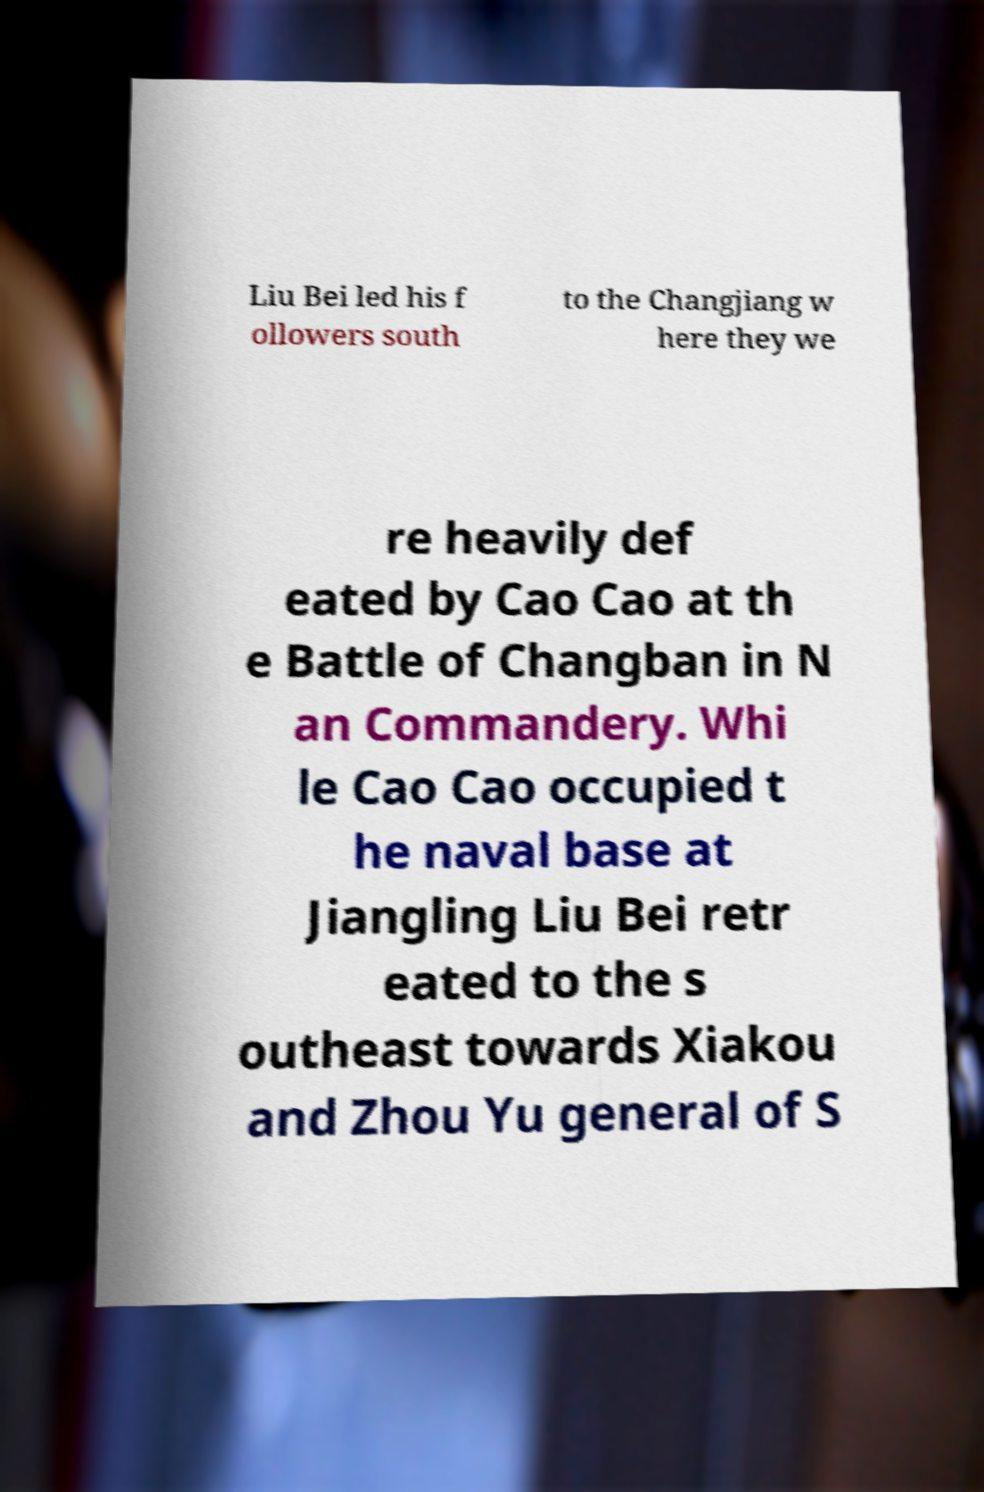Can you read and provide the text displayed in the image?This photo seems to have some interesting text. Can you extract and type it out for me? Liu Bei led his f ollowers south to the Changjiang w here they we re heavily def eated by Cao Cao at th e Battle of Changban in N an Commandery. Whi le Cao Cao occupied t he naval base at Jiangling Liu Bei retr eated to the s outheast towards Xiakou and Zhou Yu general of S 